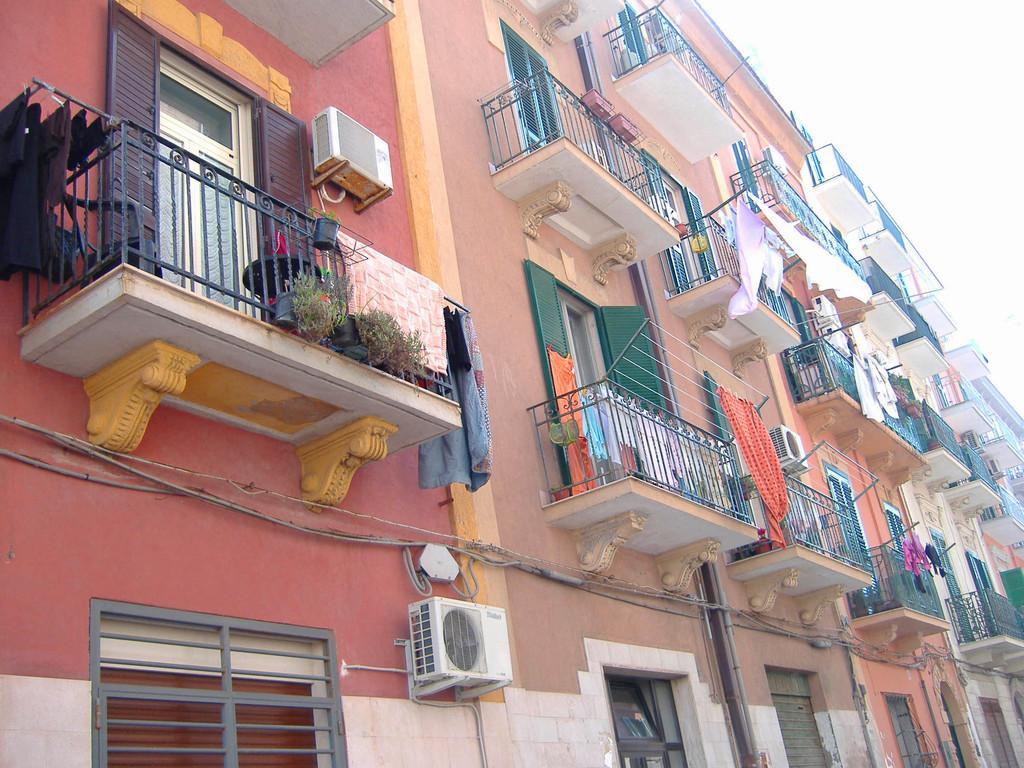Can you describe this image briefly? In this image, I can see a building with the windows, doors and iron grills. I can see the flower pots with the plants. I think these are the outdoor units of air conditioners, which are attached to the building wall. I can see the clothes hanging. 